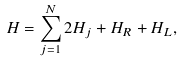<formula> <loc_0><loc_0><loc_500><loc_500>H = \sum _ { j = 1 } ^ { N } 2 H _ { j } + H _ { R } + H _ { L } ,</formula> 